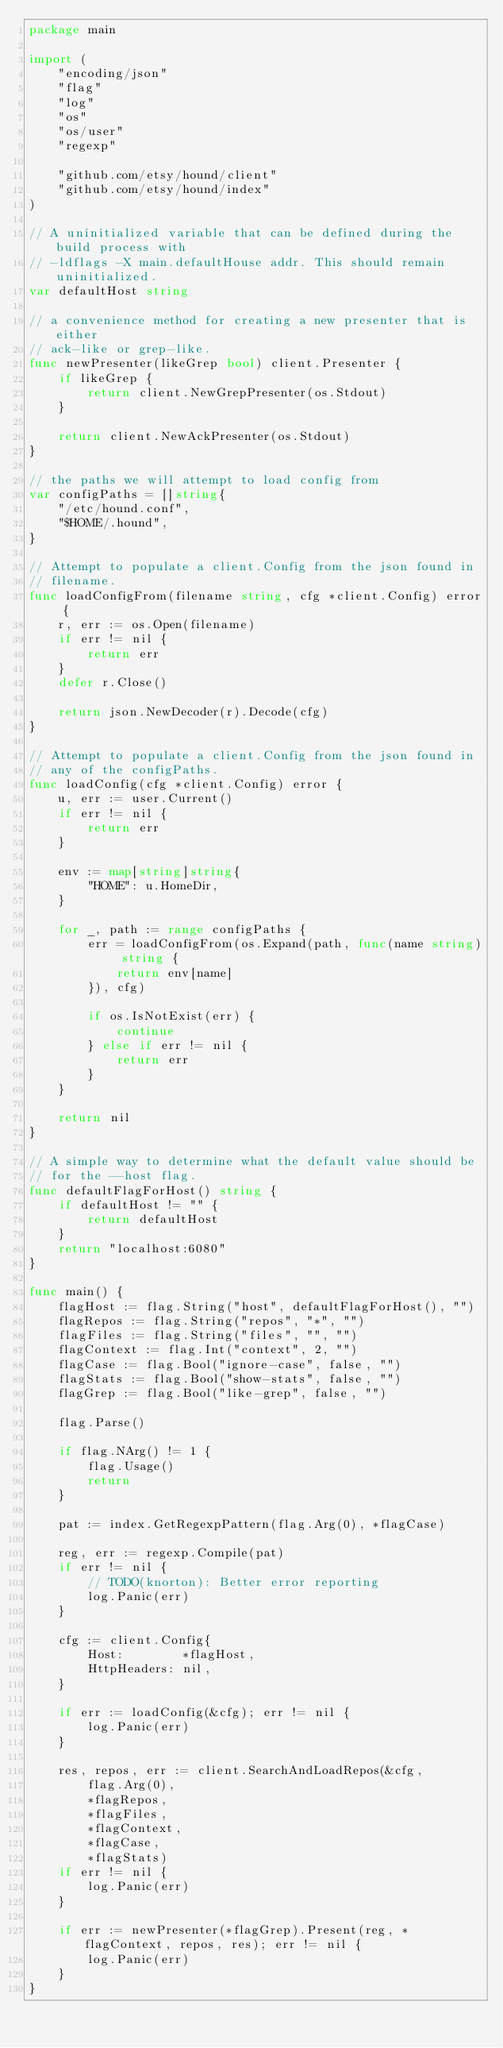Convert code to text. <code><loc_0><loc_0><loc_500><loc_500><_Go_>package main

import (
	"encoding/json"
	"flag"
	"log"
	"os"
	"os/user"
	"regexp"

	"github.com/etsy/hound/client"
	"github.com/etsy/hound/index"
)

// A uninitialized variable that can be defined during the build process with
// -ldflags -X main.defaultHouse addr. This should remain uninitialized.
var defaultHost string

// a convenience method for creating a new presenter that is either
// ack-like or grep-like.
func newPresenter(likeGrep bool) client.Presenter {
	if likeGrep {
		return client.NewGrepPresenter(os.Stdout)
	}

	return client.NewAckPresenter(os.Stdout)
}

// the paths we will attempt to load config from
var configPaths = []string{
	"/etc/hound.conf",
	"$HOME/.hound",
}

// Attempt to populate a client.Config from the json found in
// filename.
func loadConfigFrom(filename string, cfg *client.Config) error {
	r, err := os.Open(filename)
	if err != nil {
		return err
	}
	defer r.Close()

	return json.NewDecoder(r).Decode(cfg)
}

// Attempt to populate a client.Config from the json found in
// any of the configPaths.
func loadConfig(cfg *client.Config) error {
	u, err := user.Current()
	if err != nil {
		return err
	}

	env := map[string]string{
		"HOME": u.HomeDir,
	}

	for _, path := range configPaths {
		err = loadConfigFrom(os.Expand(path, func(name string) string {
			return env[name]
		}), cfg)

		if os.IsNotExist(err) {
			continue
		} else if err != nil {
			return err
		}
	}

	return nil
}

// A simple way to determine what the default value should be
// for the --host flag.
func defaultFlagForHost() string {
	if defaultHost != "" {
		return defaultHost
	}
	return "localhost:6080"
}

func main() {
	flagHost := flag.String("host", defaultFlagForHost(), "")
	flagRepos := flag.String("repos", "*", "")
	flagFiles := flag.String("files", "", "")
	flagContext := flag.Int("context", 2, "")
	flagCase := flag.Bool("ignore-case", false, "")
	flagStats := flag.Bool("show-stats", false, "")
	flagGrep := flag.Bool("like-grep", false, "")

	flag.Parse()

	if flag.NArg() != 1 {
		flag.Usage()
		return
	}

	pat := index.GetRegexpPattern(flag.Arg(0), *flagCase)

	reg, err := regexp.Compile(pat)
	if err != nil {
		// TODO(knorton): Better error reporting
		log.Panic(err)
	}

	cfg := client.Config{
		Host:        *flagHost,
		HttpHeaders: nil,
	}

	if err := loadConfig(&cfg); err != nil {
		log.Panic(err)
	}

	res, repos, err := client.SearchAndLoadRepos(&cfg,
		flag.Arg(0),
		*flagRepos,
		*flagFiles,
		*flagContext,
		*flagCase,
		*flagStats)
	if err != nil {
		log.Panic(err)
	}

	if err := newPresenter(*flagGrep).Present(reg, *flagContext, repos, res); err != nil {
		log.Panic(err)
	}
}
</code> 